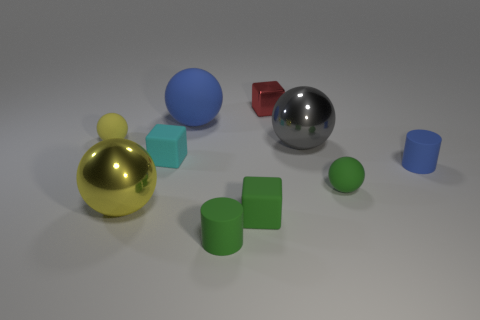What number of objects are either small spheres right of the small red metallic block or tiny red objects?
Give a very brief answer. 2. What number of other objects are the same size as the green rubber block?
Offer a very short reply. 6. There is a blue thing on the right side of the blue rubber sphere; how big is it?
Provide a short and direct response. Small. What is the shape of the tiny red thing that is the same material as the big gray object?
Provide a succinct answer. Cube. Is there anything else of the same color as the big matte ball?
Ensure brevity in your answer.  Yes. What is the color of the large object to the left of the small cyan matte block that is right of the large yellow metallic sphere?
Your answer should be very brief. Yellow. How many big objects are either gray metallic balls or gray rubber balls?
Offer a very short reply. 1. There is a tiny yellow object that is the same shape as the large blue thing; what material is it?
Your response must be concise. Rubber. Is there anything else that has the same material as the large blue sphere?
Ensure brevity in your answer.  Yes. The big rubber thing is what color?
Offer a very short reply. Blue. 